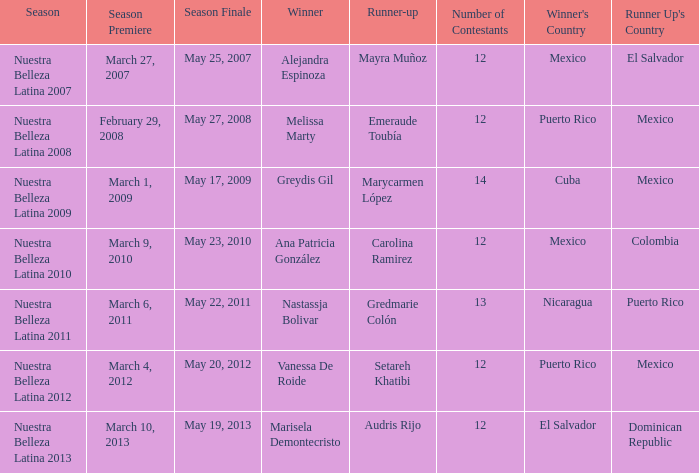How many contestants were there on March 1, 2009 during the season premiere? 14.0. 